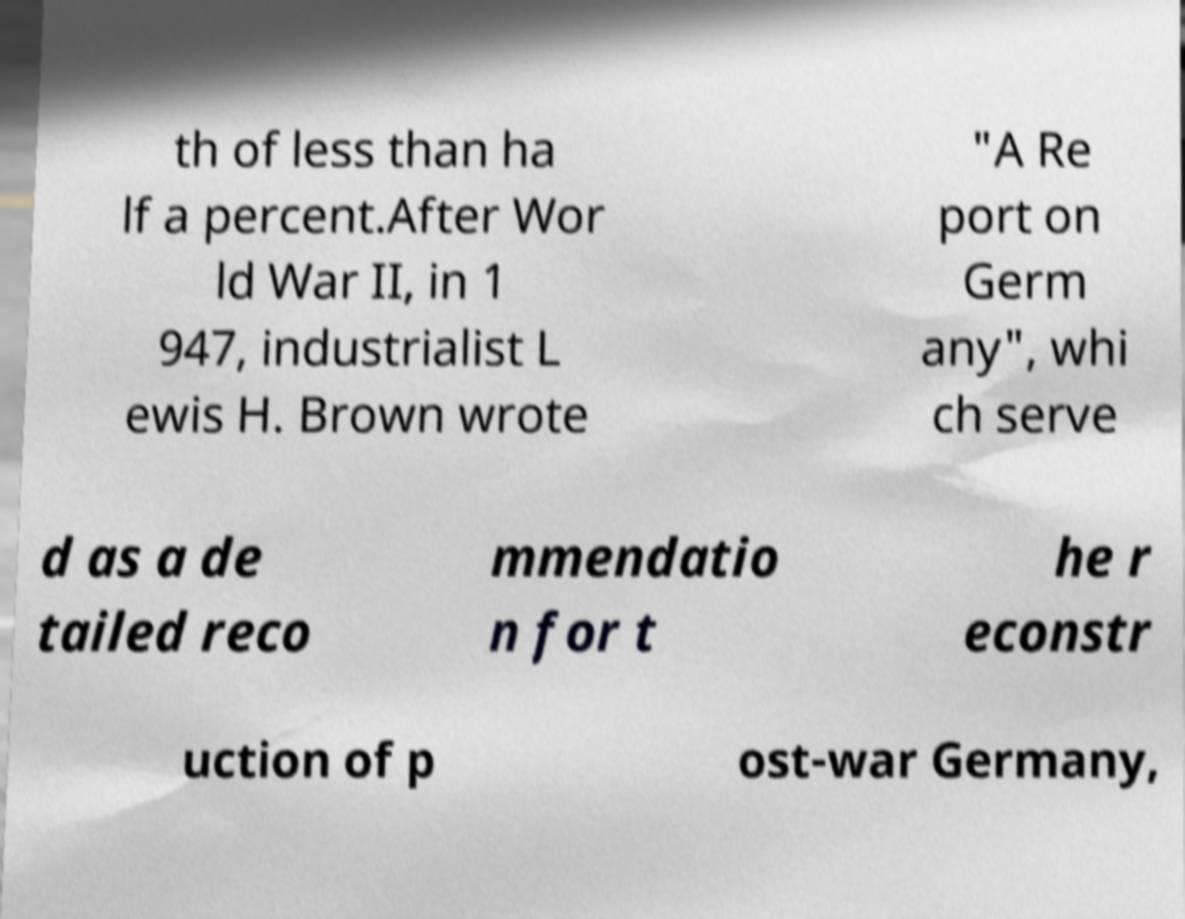Could you extract and type out the text from this image? th of less than ha lf a percent.After Wor ld War II, in 1 947, industrialist L ewis H. Brown wrote "A Re port on Germ any", whi ch serve d as a de tailed reco mmendatio n for t he r econstr uction of p ost-war Germany, 